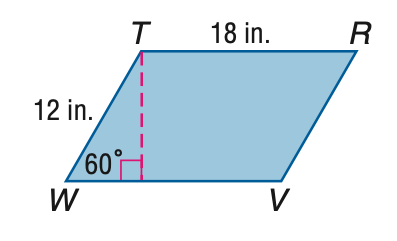Answer the mathemtical geometry problem and directly provide the correct option letter.
Question: Find the area of \parallelogram T R V W.
Choices: A: 108 B: 108 \sqrt 2 C: 108 \sqrt 3 D: 216 C 